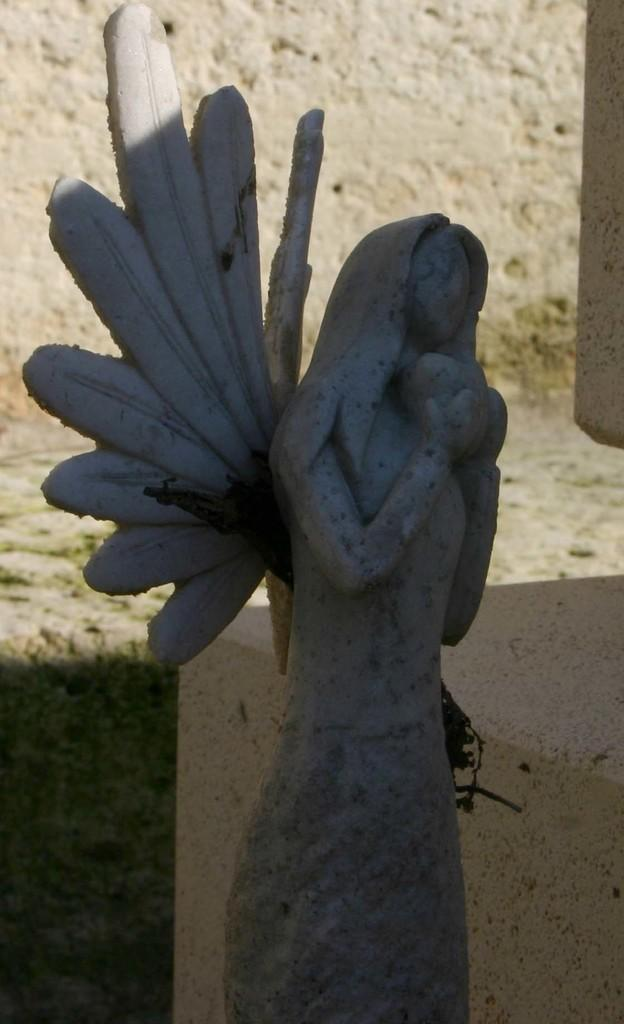What is the main subject of the image? There is a sculpture in the image. What can be seen in the background of the image? There is grass and a wall in the background of the image. What type of jam is being spread on the sidewalk in the image? There is no jam or sidewalk present in the image; it features a sculpture and a background with grass and a wall. 